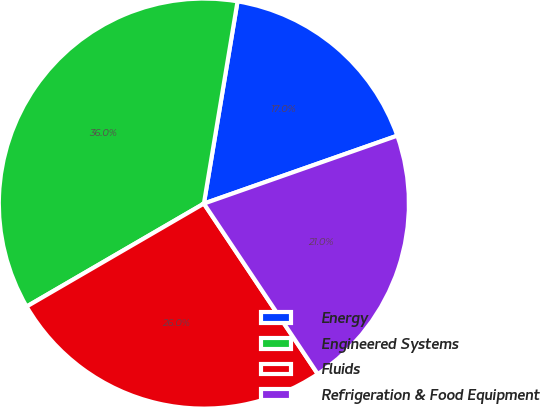Convert chart. <chart><loc_0><loc_0><loc_500><loc_500><pie_chart><fcel>Energy<fcel>Engineered Systems<fcel>Fluids<fcel>Refrigeration & Food Equipment<nl><fcel>17.0%<fcel>36.0%<fcel>26.0%<fcel>21.0%<nl></chart> 